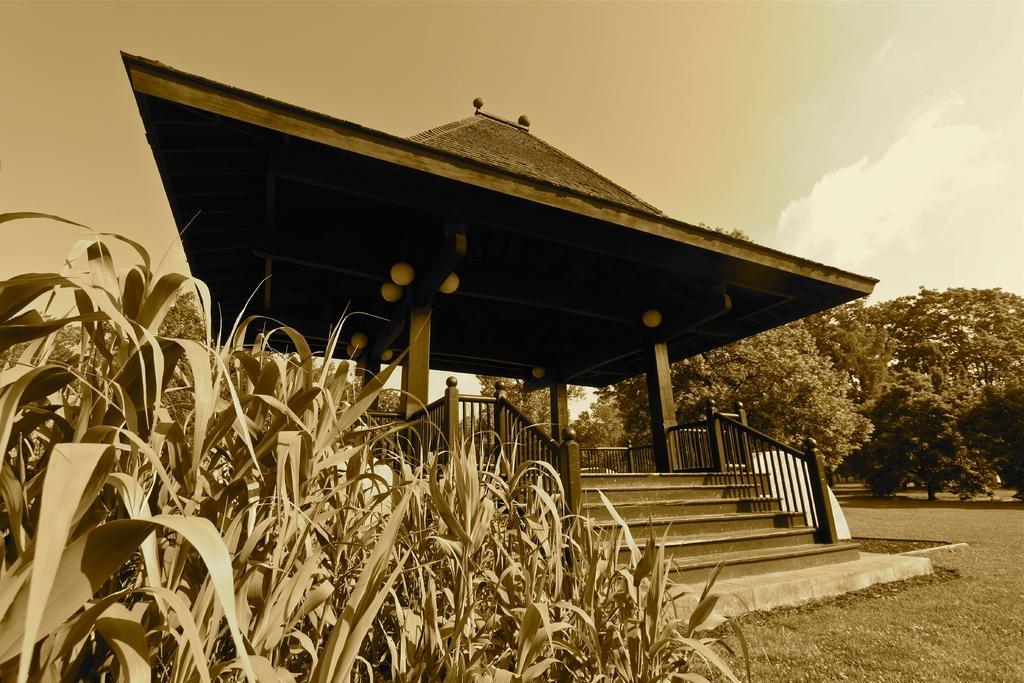In one or two sentences, can you explain what this image depicts? In this image I can see black and white image and I can see the sky at the top and in the middle I can see a roof and staircase, trees, grass visible. 